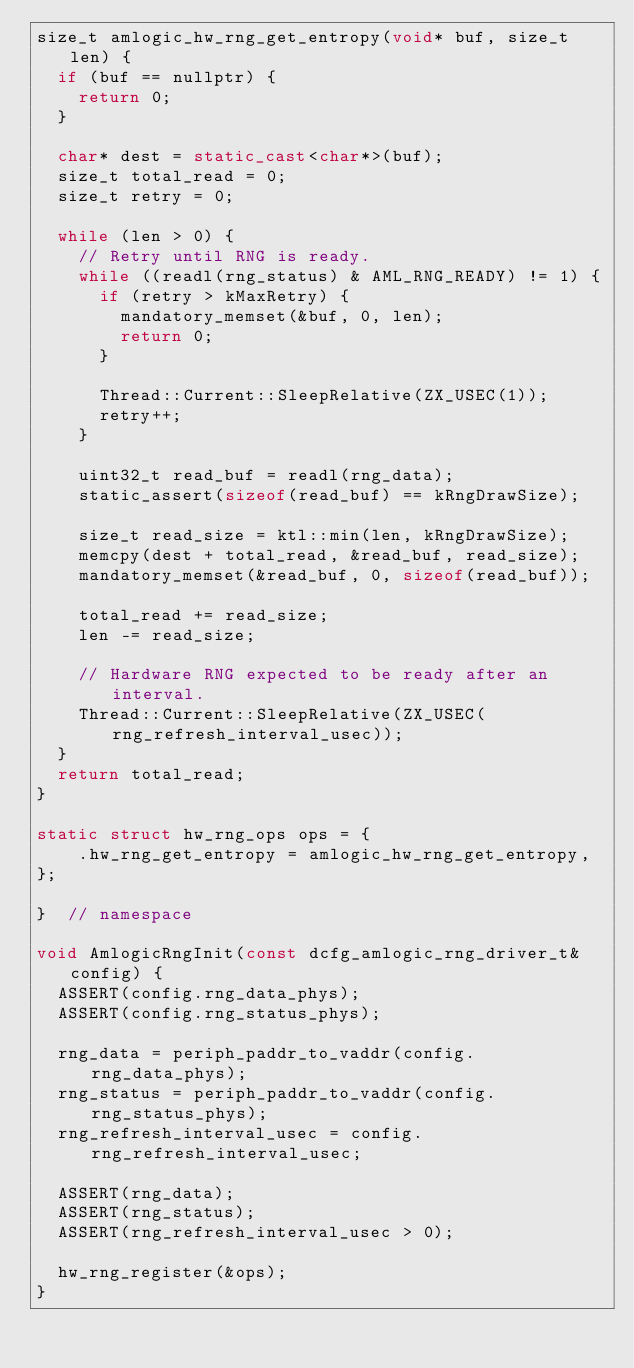<code> <loc_0><loc_0><loc_500><loc_500><_C++_>size_t amlogic_hw_rng_get_entropy(void* buf, size_t len) {
  if (buf == nullptr) {
    return 0;
  }

  char* dest = static_cast<char*>(buf);
  size_t total_read = 0;
  size_t retry = 0;

  while (len > 0) {
    // Retry until RNG is ready.
    while ((readl(rng_status) & AML_RNG_READY) != 1) {
      if (retry > kMaxRetry) {
        mandatory_memset(&buf, 0, len);
        return 0;
      }

      Thread::Current::SleepRelative(ZX_USEC(1));
      retry++;
    }

    uint32_t read_buf = readl(rng_data);
    static_assert(sizeof(read_buf) == kRngDrawSize);

    size_t read_size = ktl::min(len, kRngDrawSize);
    memcpy(dest + total_read, &read_buf, read_size);
    mandatory_memset(&read_buf, 0, sizeof(read_buf));

    total_read += read_size;
    len -= read_size;

    // Hardware RNG expected to be ready after an interval.
    Thread::Current::SleepRelative(ZX_USEC(rng_refresh_interval_usec));
  }
  return total_read;
}

static struct hw_rng_ops ops = {
    .hw_rng_get_entropy = amlogic_hw_rng_get_entropy,
};

}  // namespace

void AmlogicRngInit(const dcfg_amlogic_rng_driver_t& config) {
  ASSERT(config.rng_data_phys);
  ASSERT(config.rng_status_phys);

  rng_data = periph_paddr_to_vaddr(config.rng_data_phys);
  rng_status = periph_paddr_to_vaddr(config.rng_status_phys);
  rng_refresh_interval_usec = config.rng_refresh_interval_usec;

  ASSERT(rng_data);
  ASSERT(rng_status);
  ASSERT(rng_refresh_interval_usec > 0);

  hw_rng_register(&ops);
}
</code> 